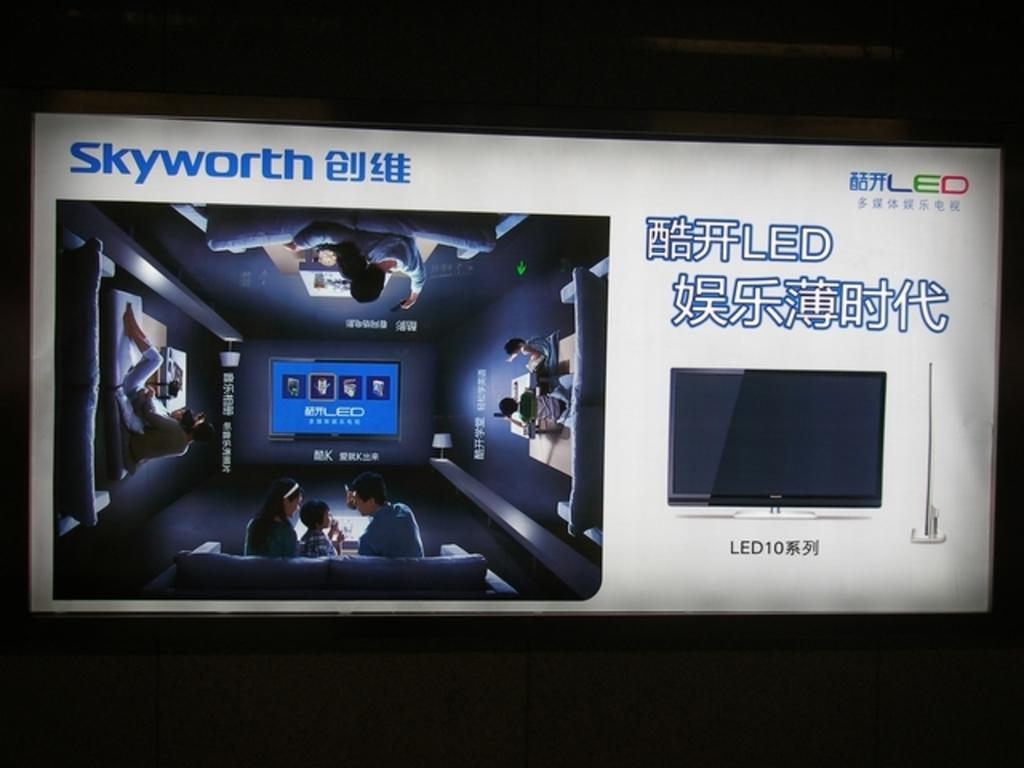<image>
Offer a succinct explanation of the picture presented. An ad for a Skyworth LED TV shows a family sitting in their home theater. 